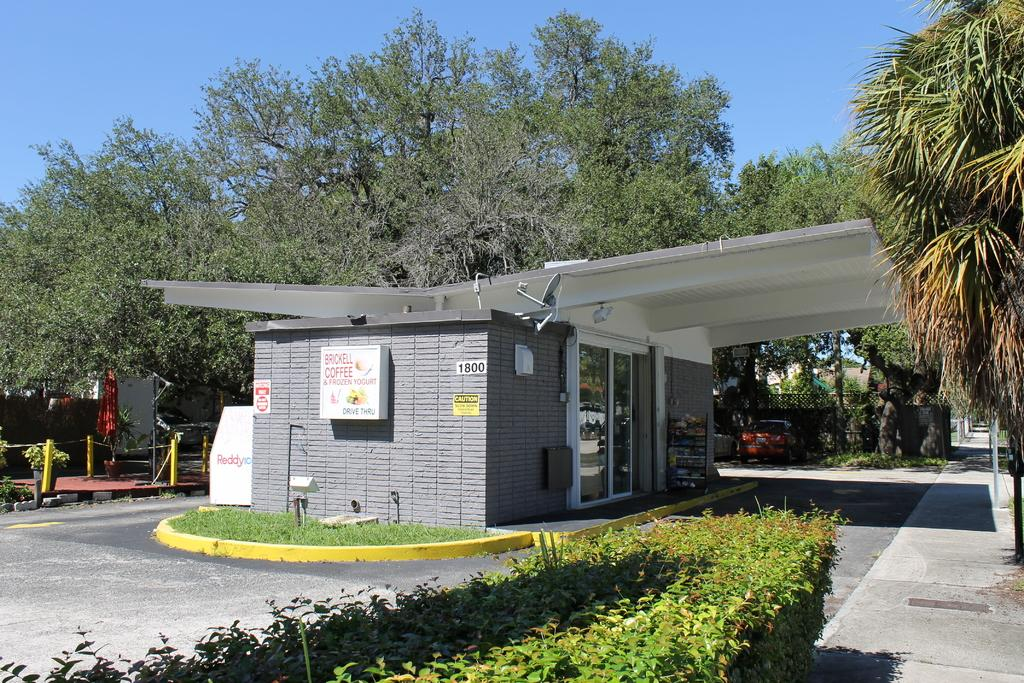What type of establishment is located in the middle of the image? There is a store in the middle of the image. What can be seen behind the store in the image? There are trees at the back side of the image. What is visible at the top of the image? The sky is visible at the top of the image. What level of the organization is depicted in the image? There is no indication of an organization or a specific level in the image. The image only shows a store, trees, and the sky. 